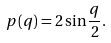<formula> <loc_0><loc_0><loc_500><loc_500>p ( q ) = 2 \sin \frac { q } { 2 } .</formula> 